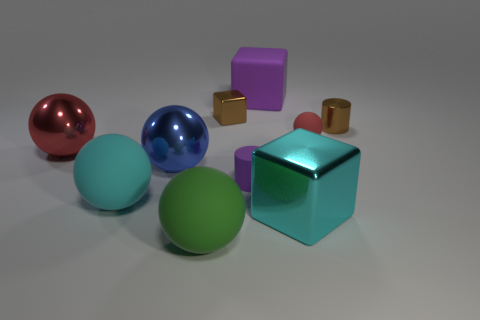Is the matte cube the same color as the tiny matte cylinder?
Your response must be concise. Yes. How many metallic things are right of the matte object that is behind the matte sphere right of the matte cube?
Give a very brief answer. 2. The large purple object that is made of the same material as the tiny purple cylinder is what shape?
Keep it short and to the point. Cube. What material is the large block that is in front of the tiny shiny thing that is on the right side of the cylinder that is in front of the red matte ball made of?
Make the answer very short. Metal. How many things are red metallic spheres behind the green ball or small yellow cylinders?
Offer a terse response. 1. How many other objects are the same shape as the cyan rubber object?
Offer a terse response. 4. Is the number of cyan metallic cubes on the right side of the big blue thing greater than the number of large blue rubber cylinders?
Your response must be concise. Yes. There is a red matte object that is the same shape as the cyan matte thing; what is its size?
Make the answer very short. Small. The big purple thing is what shape?
Offer a terse response. Cube. What shape is the red thing that is the same size as the matte cylinder?
Give a very brief answer. Sphere. 